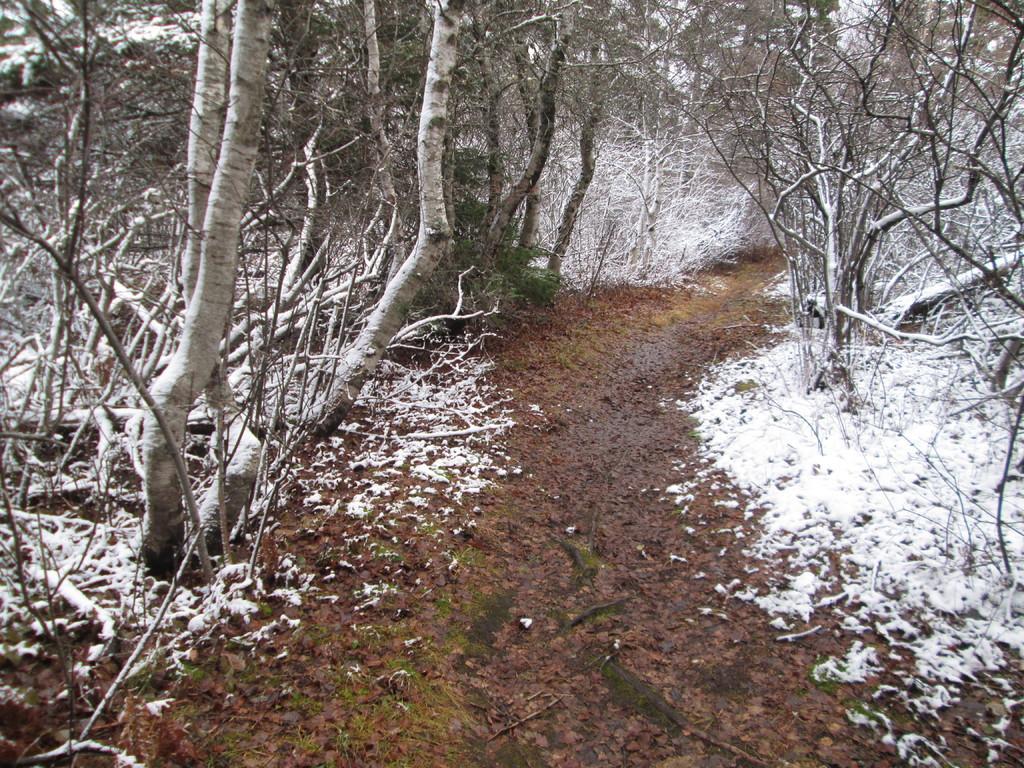Please provide a concise description of this image. In this image, we can see trees and at the bottom, there is ground and we can see snow. 